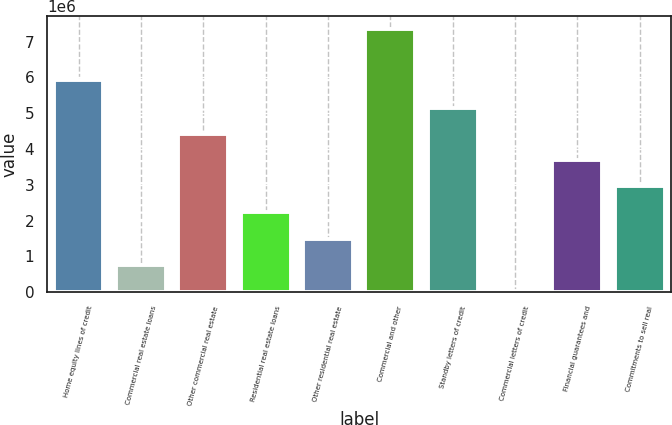<chart> <loc_0><loc_0><loc_500><loc_500><bar_chart><fcel>Home equity lines of credit<fcel>Commercial real estate loans<fcel>Other commercial real estate<fcel>Residential real estate loans<fcel>Other residential real estate<fcel>Commercial and other<fcel>Standby letters of credit<fcel>Commercial letters of credit<fcel>Financial guarantees and<fcel>Commitments to sell real<nl><fcel>5.9379e+06<fcel>765374<fcel>4.42172e+06<fcel>2.22791e+06<fcel>1.49664e+06<fcel>7.34679e+06<fcel>5.15298e+06<fcel>34105<fcel>3.69045e+06<fcel>2.95918e+06<nl></chart> 